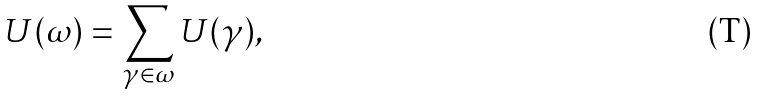<formula> <loc_0><loc_0><loc_500><loc_500>U ( \omega ) = \sum _ { \gamma \in \omega } U ( \gamma ) ,</formula> 